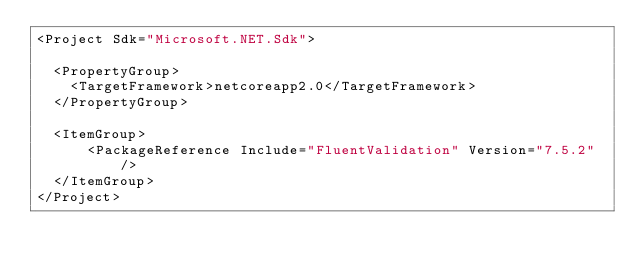Convert code to text. <code><loc_0><loc_0><loc_500><loc_500><_XML_><Project Sdk="Microsoft.NET.Sdk">

  <PropertyGroup>
    <TargetFramework>netcoreapp2.0</TargetFramework>
  </PropertyGroup>

  <ItemGroup>
      <PackageReference Include="FluentValidation" Version="7.5.2" />
  </ItemGroup>
</Project>
</code> 